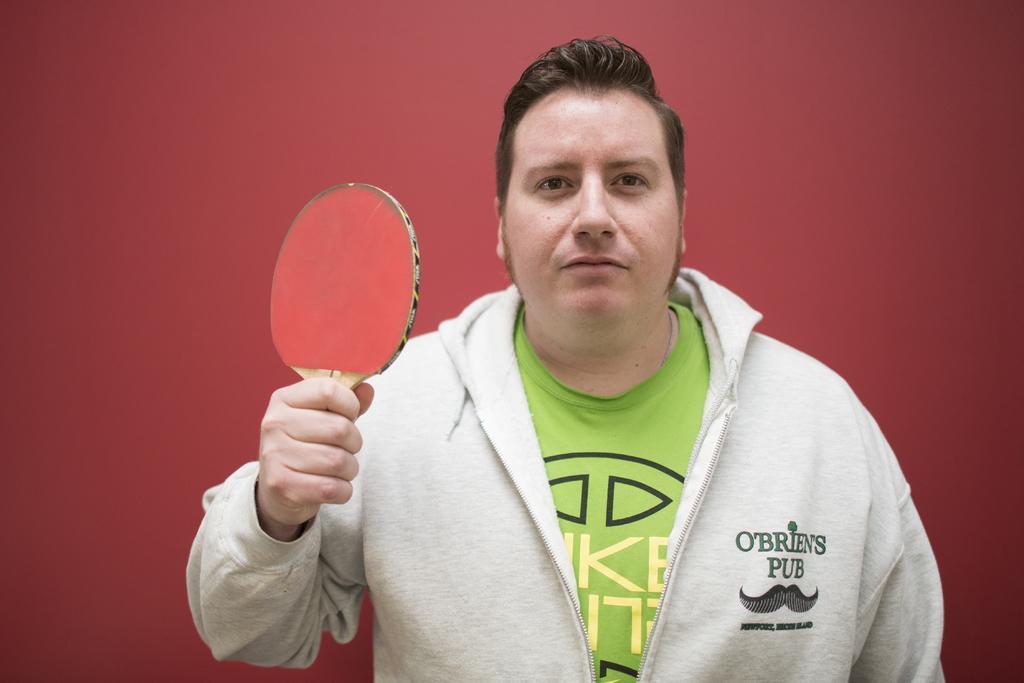In one or two sentences, can you explain what this image depicts? In this image i can see a person wearing a white jacket and green t shirt, and he is holding a bat in his hand. 